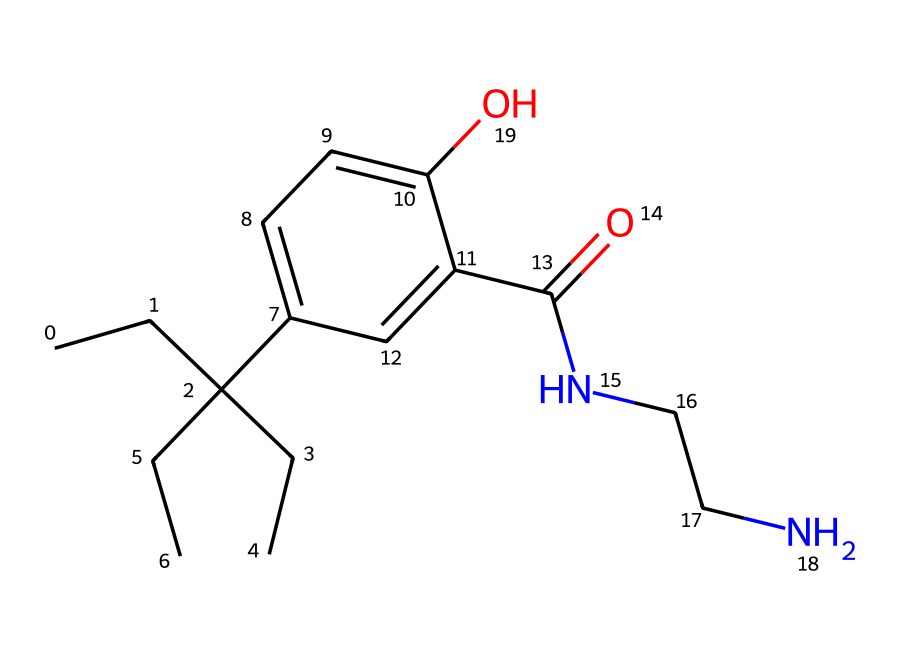What is the main functional group in this chemical? The structure shows a carbonyl group (C=O) indicated by the presence of a carbon double bonded to an oxygen atom, characteristic of amides.
Answer: carbonyl group How many nitrogen atoms are present in the structure? Analyzing the structure, there are two nitrogen atoms present in the amino (–NH) groups attached to the carbon atoms.
Answer: two Is this chemical a solid, liquid, or gas at room temperature? Based on the structure's composition and the presence of aromatic rings, it is typically a solid or a viscous liquid at room temperature.
Answer: solid What type of drug category does this compound fall into? The presence of the carbonyl and amine functional groups indicates it is classified as an opioid.
Answer: opioid What is the total number of hydroxyl groups in the structure? By examining the structure, there is one hydroxyl (–OH) group represented, which contributes to the overall polarity of the molecule.
Answer: one What are the possible respiratory effects of this compound when inhaled? Given its opioid classification, inhalation can lead to respiratory depression, affecting breathing rates and depth.
Answer: respiratory depression 